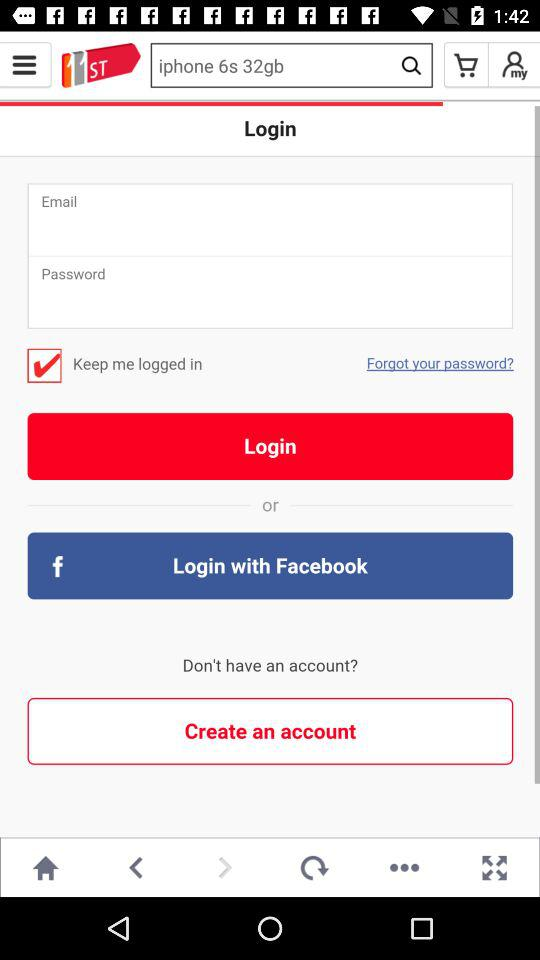Which tab is selected? The selected tab is "HOME". 